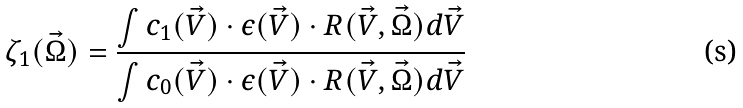<formula> <loc_0><loc_0><loc_500><loc_500>\zeta _ { 1 } ( \vec { \Omega } ) = \frac { \int c _ { 1 } ( \vec { V } ) \cdot \epsilon ( \vec { V } ) \cdot R ( \vec { V } , \vec { \Omega } ) d \vec { V } } { \int c _ { 0 } ( \vec { V } ) \cdot \epsilon ( \vec { V } ) \cdot R ( \vec { V } , \vec { \Omega } ) d \vec { V } }</formula> 